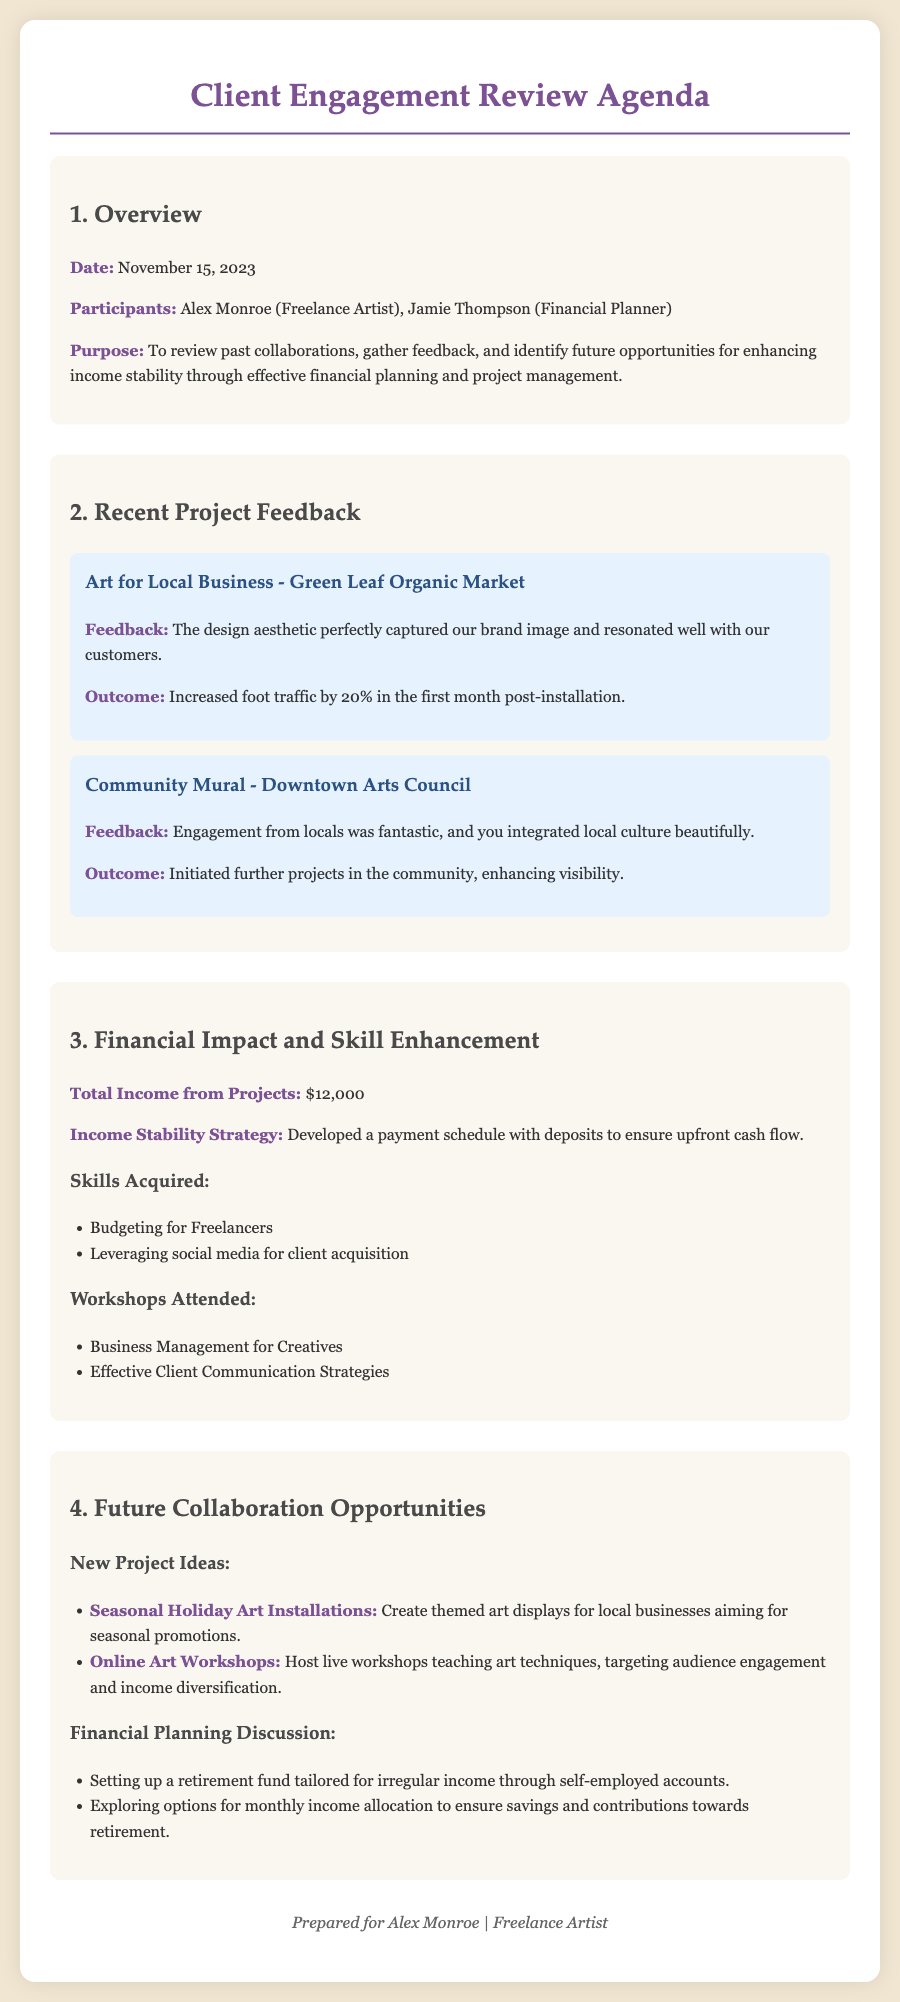what is the date of the meeting? The date of the meeting is stated at the beginning in the overview section.
Answer: November 15, 2023 who are the participants in the meeting? The participants are listed under the overview section of the document.
Answer: Alex Monroe (Freelance Artist), Jamie Thompson (Financial Planner) what was the total income from projects? The total income is explicitly mentioned in the financial impact section of the document.
Answer: $12,000 what percentage increase in foot traffic was reported for the Green Leaf Organic Market project? The percentage increase is found in the feedback summary for the relevant project.
Answer: 20% which skill was acquired related to client acquisition? The skills acquired are listed under the financial impact and skill enhancement section.
Answer: Leveraging social media for client acquisition what new project idea involves seasonal promotions? The new project ideas are detailed in the section regarding future collaboration opportunities.
Answer: Seasonal Holiday Art Installations how many workshops did Alex attend? The number of workshops is determined by counting the items listed under workshops attended.
Answer: 2 what is one financial planning discussion point mentioned? The financial planning discussion points are listed in the future collaboration opportunities section.
Answer: Setting up a retirement fund tailored for irregular income through self-employed accounts 